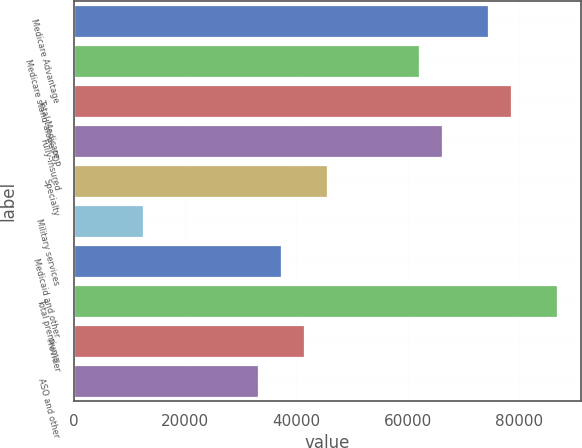Convert chart. <chart><loc_0><loc_0><loc_500><loc_500><bar_chart><fcel>Medicare Advantage<fcel>Medicare stand-alone PDP<fcel>Total Medicare<fcel>Fully-insured<fcel>Specialty<fcel>Military services<fcel>Medicaid and other<fcel>Total premiums<fcel>Provider<fcel>ASO and other<nl><fcel>74361.7<fcel>61968.4<fcel>78492.8<fcel>66099.5<fcel>45444.1<fcel>12395.4<fcel>37181.9<fcel>86755<fcel>41313<fcel>33050.8<nl></chart> 